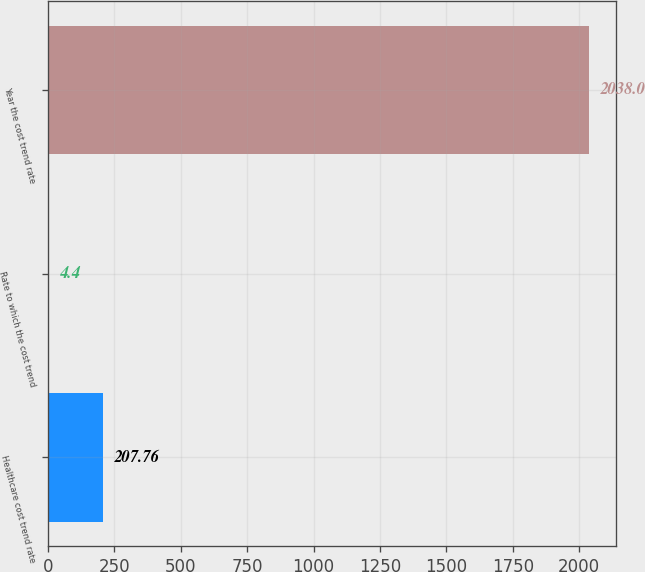Convert chart to OTSL. <chart><loc_0><loc_0><loc_500><loc_500><bar_chart><fcel>Healthcare cost trend rate<fcel>Rate to which the cost trend<fcel>Year the cost trend rate<nl><fcel>207.76<fcel>4.4<fcel>2038<nl></chart> 